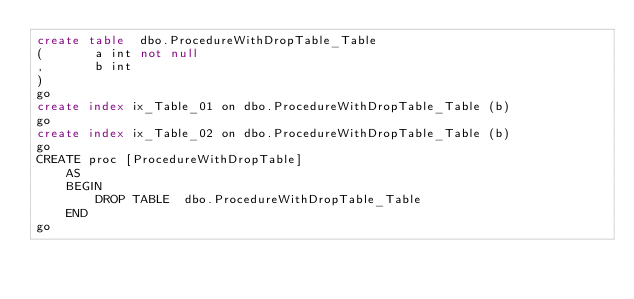<code> <loc_0><loc_0><loc_500><loc_500><_SQL_>create table  dbo.ProcedureWithDropTable_Table
(       a int not null
,       b int 
)
go
create index ix_Table_01 on dbo.ProcedureWithDropTable_Table (b)
go
create index ix_Table_02 on dbo.ProcedureWithDropTable_Table (b)
go
CREATE proc [ProcedureWithDropTable]
    AS
    BEGIN
        DROP TABLE  dbo.ProcedureWithDropTable_Table
    END
go
</code> 